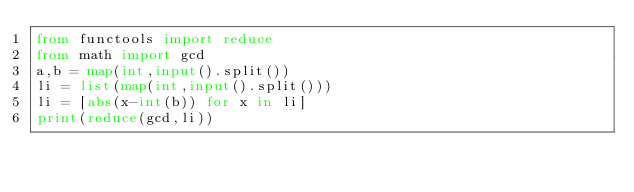Convert code to text. <code><loc_0><loc_0><loc_500><loc_500><_Python_>from functools import reduce
from math import gcd
a,b = map(int,input().split())
li = list(map(int,input().split()))
li = [abs(x-int(b)) for x in li]
print(reduce(gcd,li))</code> 